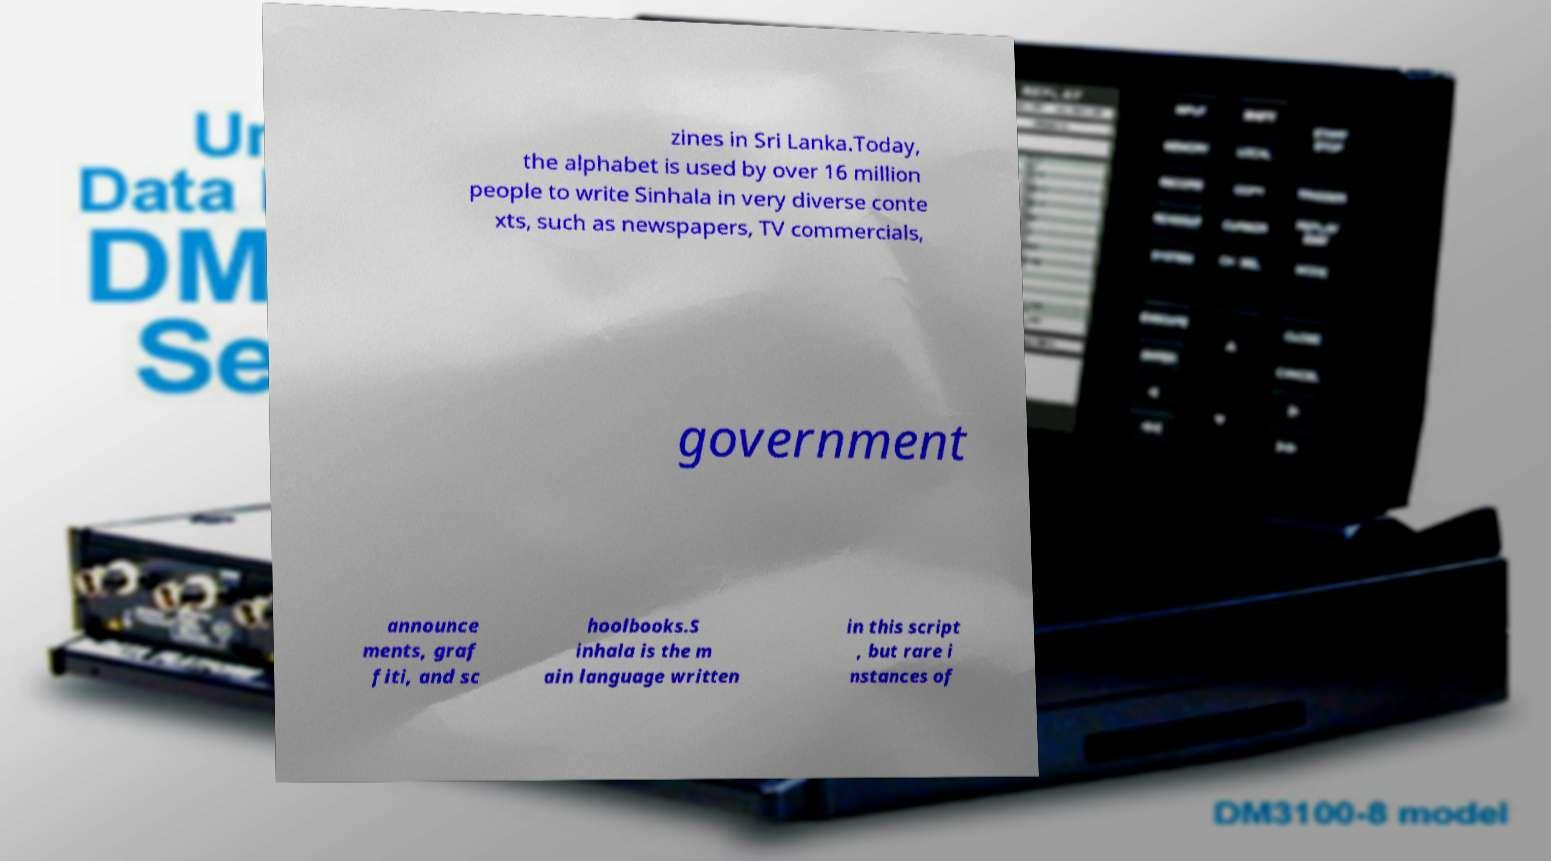Could you extract and type out the text from this image? zines in Sri Lanka.Today, the alphabet is used by over 16 million people to write Sinhala in very diverse conte xts, such as newspapers, TV commercials, government announce ments, graf fiti, and sc hoolbooks.S inhala is the m ain language written in this script , but rare i nstances of 